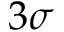<formula> <loc_0><loc_0><loc_500><loc_500>3 \sigma</formula> 